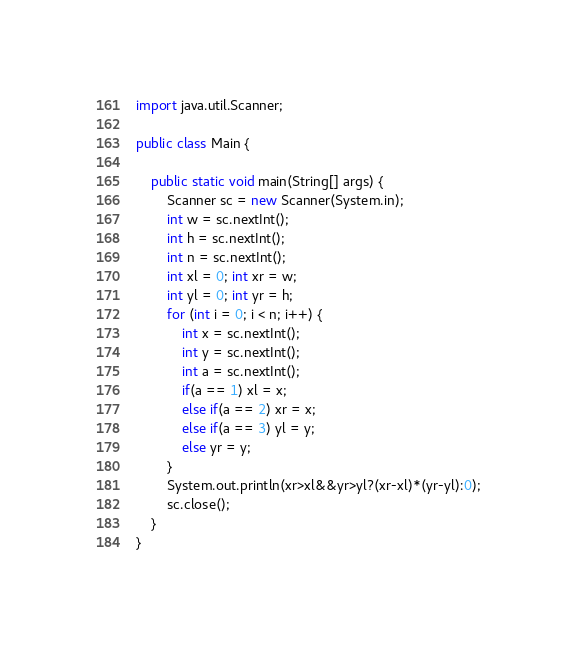Convert code to text. <code><loc_0><loc_0><loc_500><loc_500><_Java_>import java.util.Scanner;

public class Main {

	public static void main(String[] args) {
		Scanner sc = new Scanner(System.in);
		int w = sc.nextInt();
		int h = sc.nextInt();
		int n = sc.nextInt();
		int xl = 0; int xr = w;
		int yl = 0; int yr = h;
		for (int i = 0; i < n; i++) {
			int x = sc.nextInt();
			int y = sc.nextInt();
			int a = sc.nextInt();
			if(a == 1) xl = x;
			else if(a == 2) xr = x;
			else if(a == 3) yl = y;
			else yr = y;
		}
		System.out.println(xr>xl&&yr>yl?(xr-xl)*(yr-yl):0);
		sc.close();
	}
}</code> 